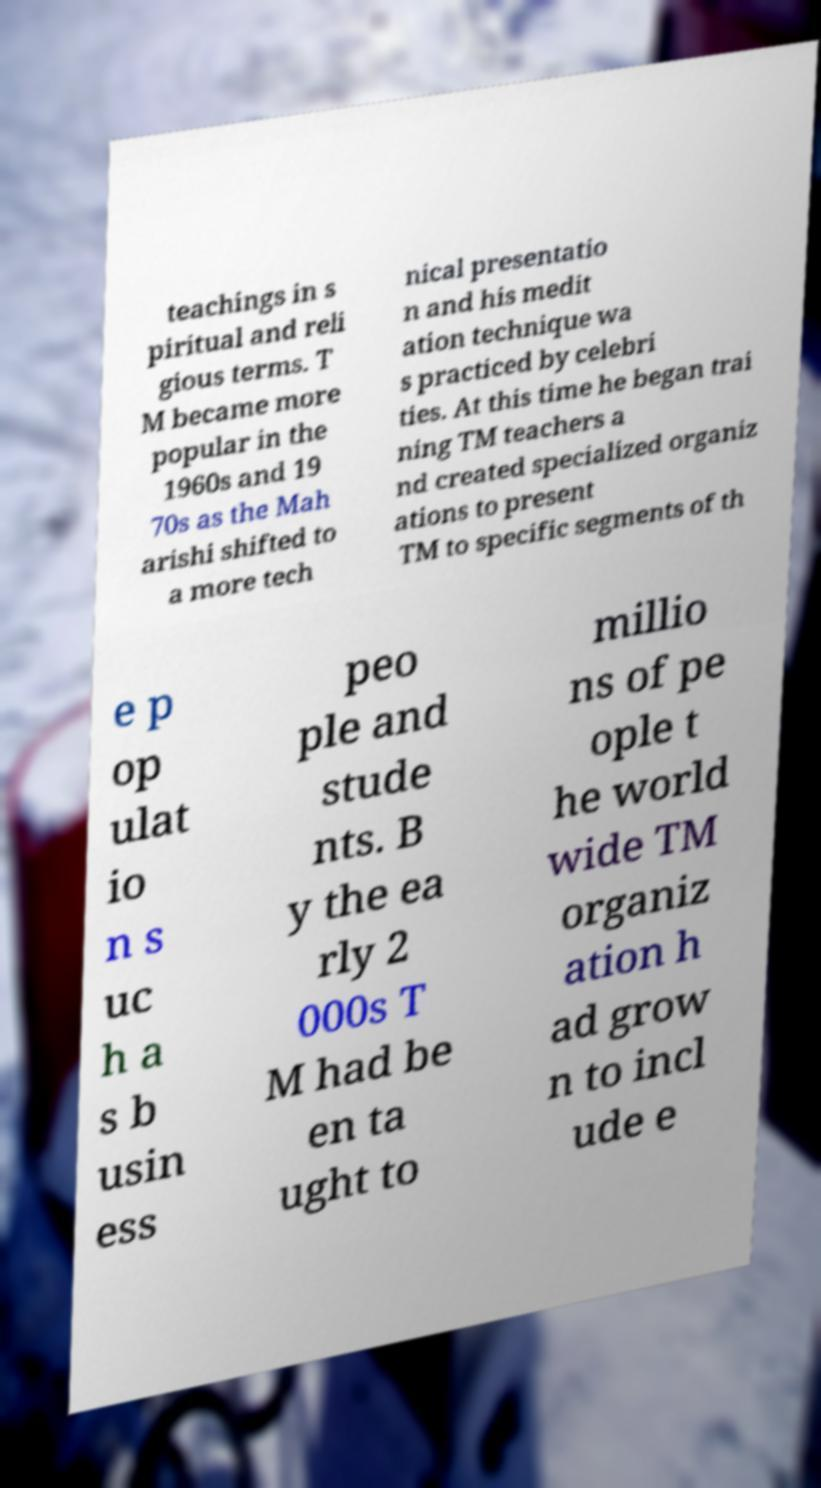Can you accurately transcribe the text from the provided image for me? teachings in s piritual and reli gious terms. T M became more popular in the 1960s and 19 70s as the Mah arishi shifted to a more tech nical presentatio n and his medit ation technique wa s practiced by celebri ties. At this time he began trai ning TM teachers a nd created specialized organiz ations to present TM to specific segments of th e p op ulat io n s uc h a s b usin ess peo ple and stude nts. B y the ea rly 2 000s T M had be en ta ught to millio ns of pe ople t he world wide TM organiz ation h ad grow n to incl ude e 